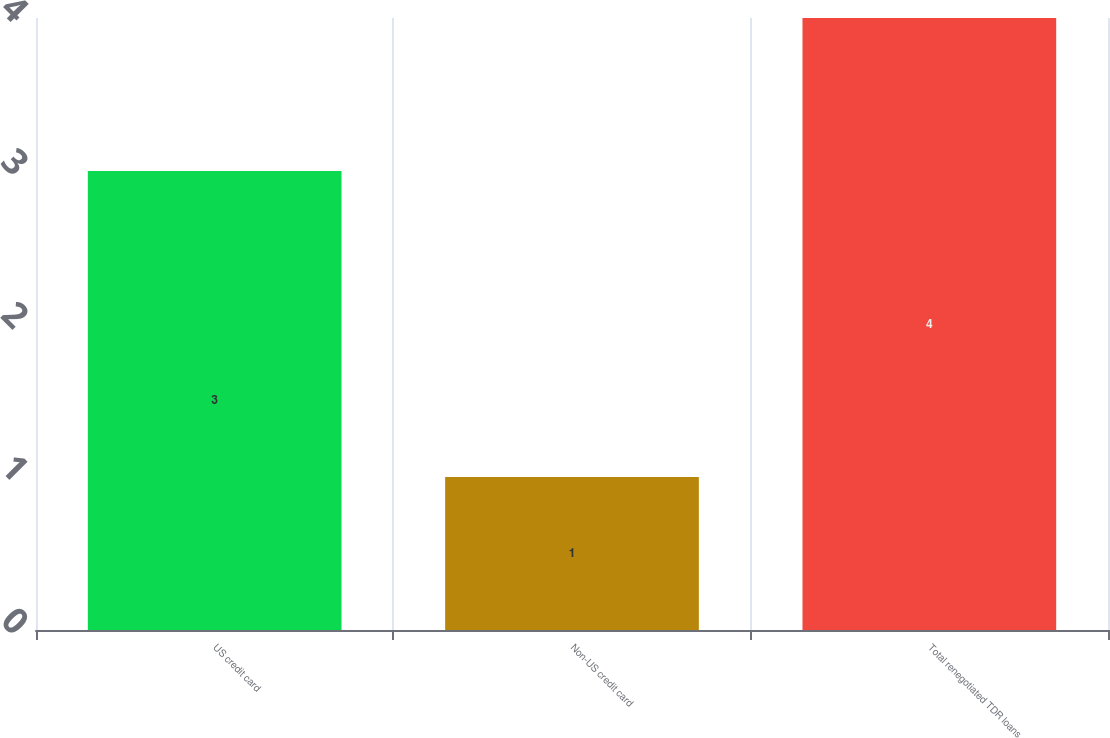Convert chart to OTSL. <chart><loc_0><loc_0><loc_500><loc_500><bar_chart><fcel>US credit card<fcel>Non-US credit card<fcel>Total renegotiated TDR loans<nl><fcel>3<fcel>1<fcel>4<nl></chart> 